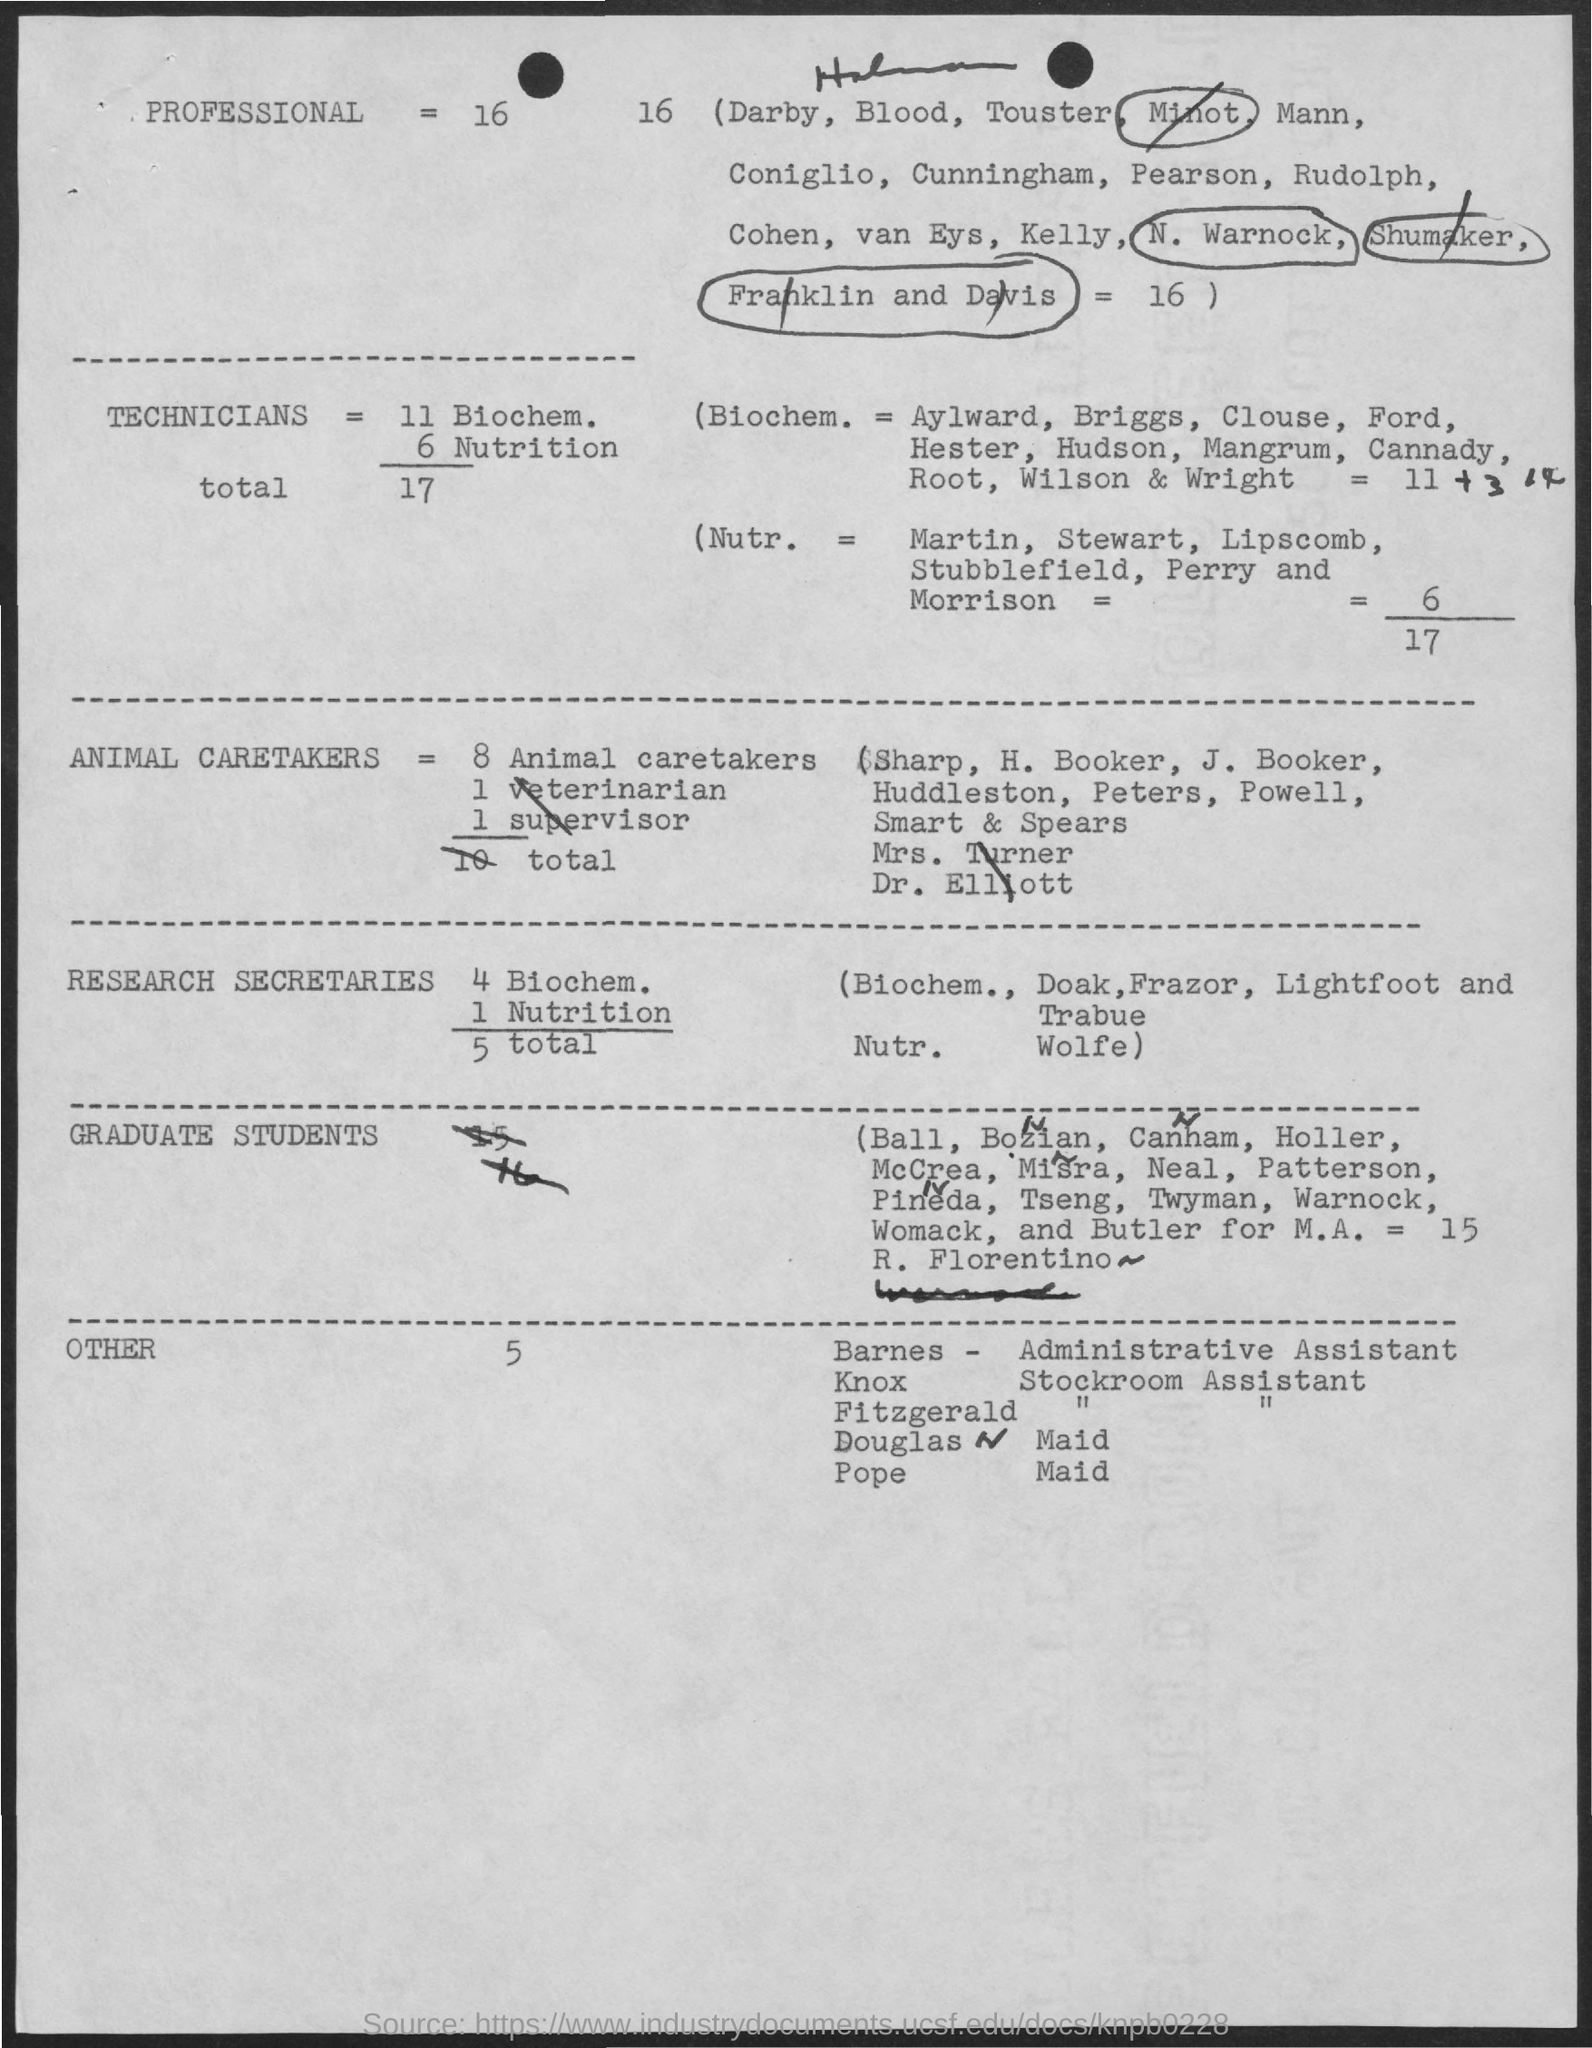Give some essential details in this illustration. The word circled in the first line is 'Minot'. 